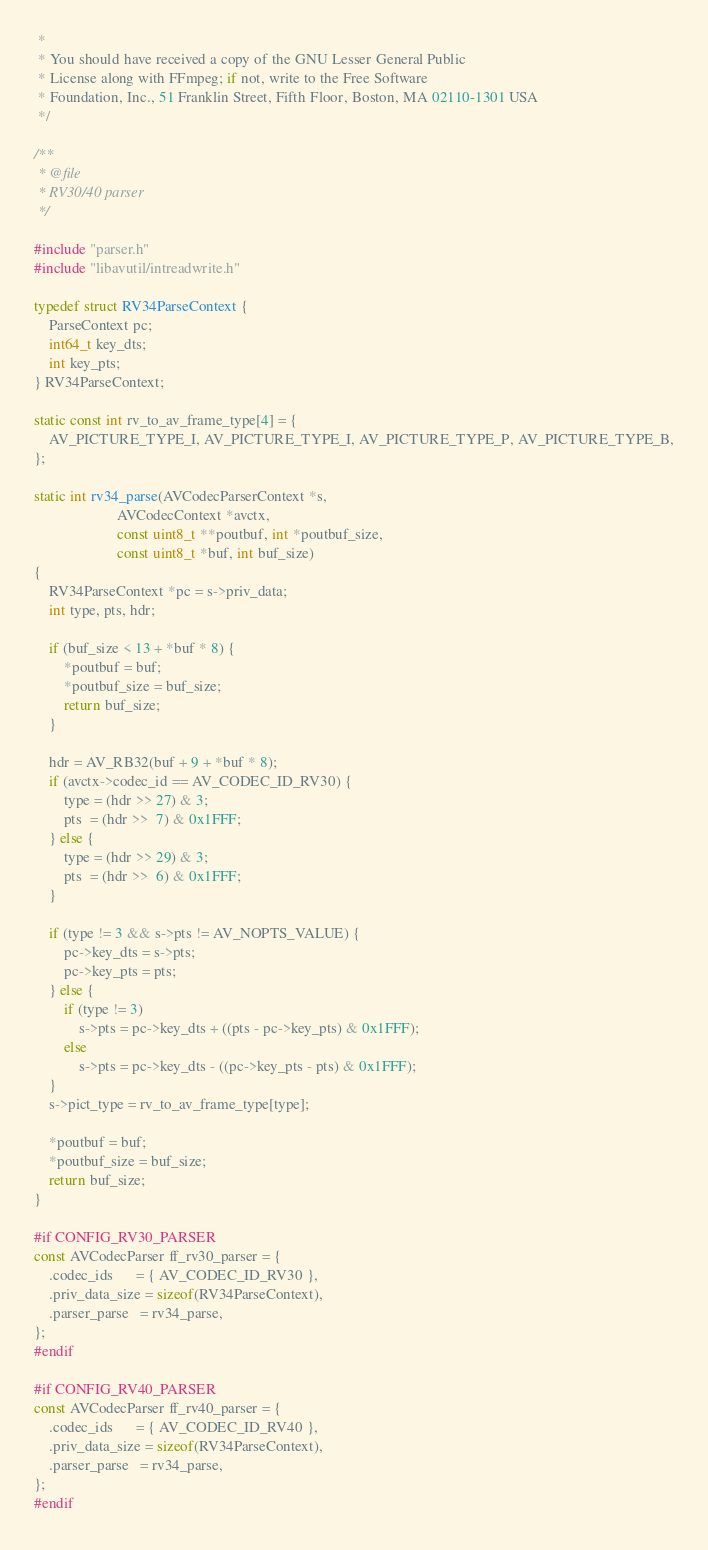<code> <loc_0><loc_0><loc_500><loc_500><_C_> *
 * You should have received a copy of the GNU Lesser General Public
 * License along with FFmpeg; if not, write to the Free Software
 * Foundation, Inc., 51 Franklin Street, Fifth Floor, Boston, MA 02110-1301 USA
 */

/**
 * @file
 * RV30/40 parser
 */

#include "parser.h"
#include "libavutil/intreadwrite.h"

typedef struct RV34ParseContext {
    ParseContext pc;
    int64_t key_dts;
    int key_pts;
} RV34ParseContext;

static const int rv_to_av_frame_type[4] = {
    AV_PICTURE_TYPE_I, AV_PICTURE_TYPE_I, AV_PICTURE_TYPE_P, AV_PICTURE_TYPE_B,
};

static int rv34_parse(AVCodecParserContext *s,
                      AVCodecContext *avctx,
                      const uint8_t **poutbuf, int *poutbuf_size,
                      const uint8_t *buf, int buf_size)
{
    RV34ParseContext *pc = s->priv_data;
    int type, pts, hdr;

    if (buf_size < 13 + *buf * 8) {
        *poutbuf = buf;
        *poutbuf_size = buf_size;
        return buf_size;
    }

    hdr = AV_RB32(buf + 9 + *buf * 8);
    if (avctx->codec_id == AV_CODEC_ID_RV30) {
        type = (hdr >> 27) & 3;
        pts  = (hdr >>  7) & 0x1FFF;
    } else {
        type = (hdr >> 29) & 3;
        pts  = (hdr >>  6) & 0x1FFF;
    }

    if (type != 3 && s->pts != AV_NOPTS_VALUE) {
        pc->key_dts = s->pts;
        pc->key_pts = pts;
    } else {
        if (type != 3)
            s->pts = pc->key_dts + ((pts - pc->key_pts) & 0x1FFF);
        else
            s->pts = pc->key_dts - ((pc->key_pts - pts) & 0x1FFF);
    }
    s->pict_type = rv_to_av_frame_type[type];

    *poutbuf = buf;
    *poutbuf_size = buf_size;
    return buf_size;
}

#if CONFIG_RV30_PARSER
const AVCodecParser ff_rv30_parser = {
    .codec_ids      = { AV_CODEC_ID_RV30 },
    .priv_data_size = sizeof(RV34ParseContext),
    .parser_parse   = rv34_parse,
};
#endif

#if CONFIG_RV40_PARSER
const AVCodecParser ff_rv40_parser = {
    .codec_ids      = { AV_CODEC_ID_RV40 },
    .priv_data_size = sizeof(RV34ParseContext),
    .parser_parse   = rv34_parse,
};
#endif
</code> 